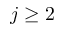Convert formula to latex. <formula><loc_0><loc_0><loc_500><loc_500>j \geq 2</formula> 